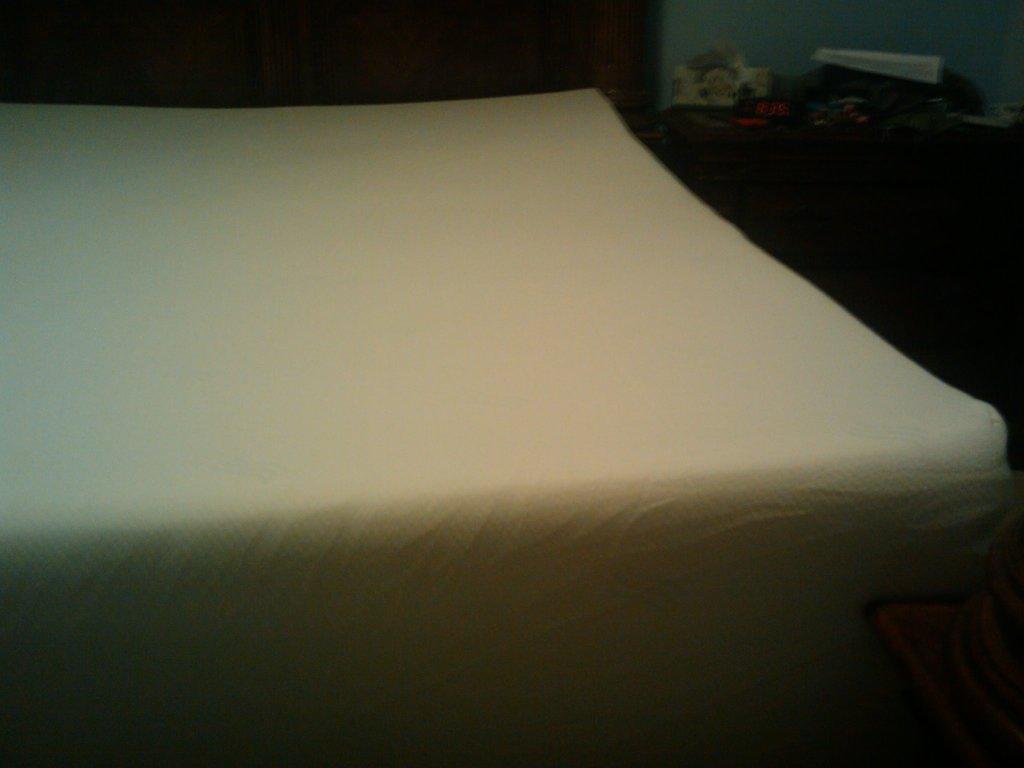In one or two sentences, can you explain what this image depicts? In this image in the center there is one bed and on the right side there are some cupboards, on the cupboards there are some objects. 